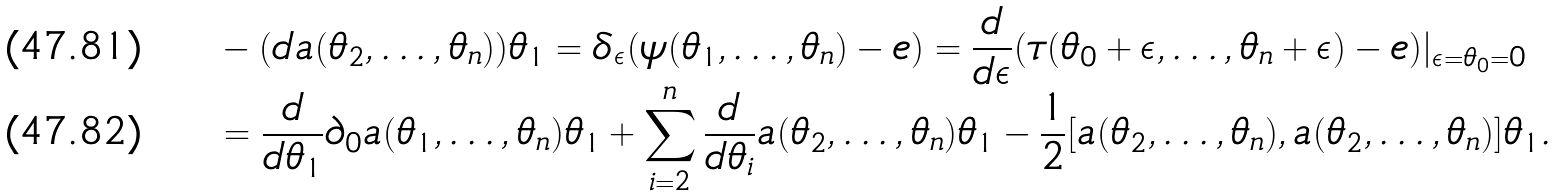Convert formula to latex. <formula><loc_0><loc_0><loc_500><loc_500>& - ( d a ( \theta _ { 2 } , \dots , \theta _ { n } ) ) \theta _ { 1 } = \delta _ { \epsilon } ( \psi ( \theta _ { 1 } , \dots , \theta _ { n } ) - e ) = \frac { d } { d \epsilon } ( \tau ( \theta _ { 0 } + \epsilon , \dots , \theta _ { n } + \epsilon ) - e ) | _ { \epsilon = \theta _ { 0 } = 0 } \\ & = \frac { d } { d \theta _ { 1 } } \partial _ { 0 } a ( \theta _ { 1 } , \dots , \theta _ { n } ) \theta _ { 1 } + \sum _ { i = 2 } ^ { n } \frac { d } { d \theta _ { i } } a ( \theta _ { 2 } , \dots , \theta _ { n } ) \theta _ { 1 } - \frac { 1 } { 2 } [ a ( \theta _ { 2 } , \dots , \theta _ { n } ) , a ( \theta _ { 2 } , \dots , \theta _ { n } ) ] \theta _ { 1 } .</formula> 